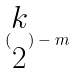<formula> <loc_0><loc_0><loc_500><loc_500>( \begin{matrix} k \\ 2 \end{matrix} ) - m</formula> 